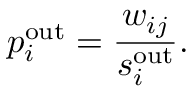Convert formula to latex. <formula><loc_0><loc_0><loc_500><loc_500>p _ { i } ^ { o u t } = \frac { w _ { i j } } { s _ { i } ^ { o u t } } .</formula> 